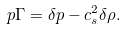Convert formula to latex. <formula><loc_0><loc_0><loc_500><loc_500>p \Gamma = \delta p - c _ { s } ^ { 2 } \delta \rho .</formula> 